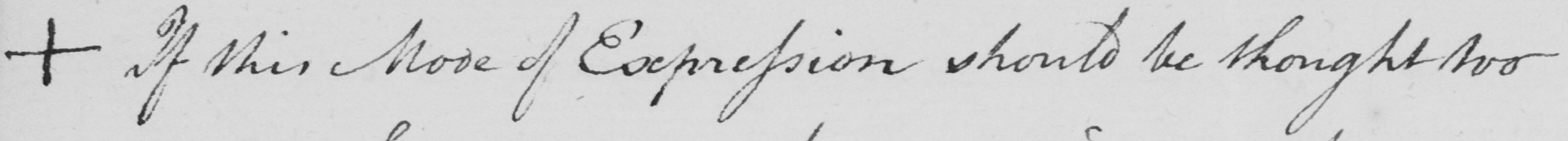What is written in this line of handwriting? +  If this Mode of Expression should be thought too 